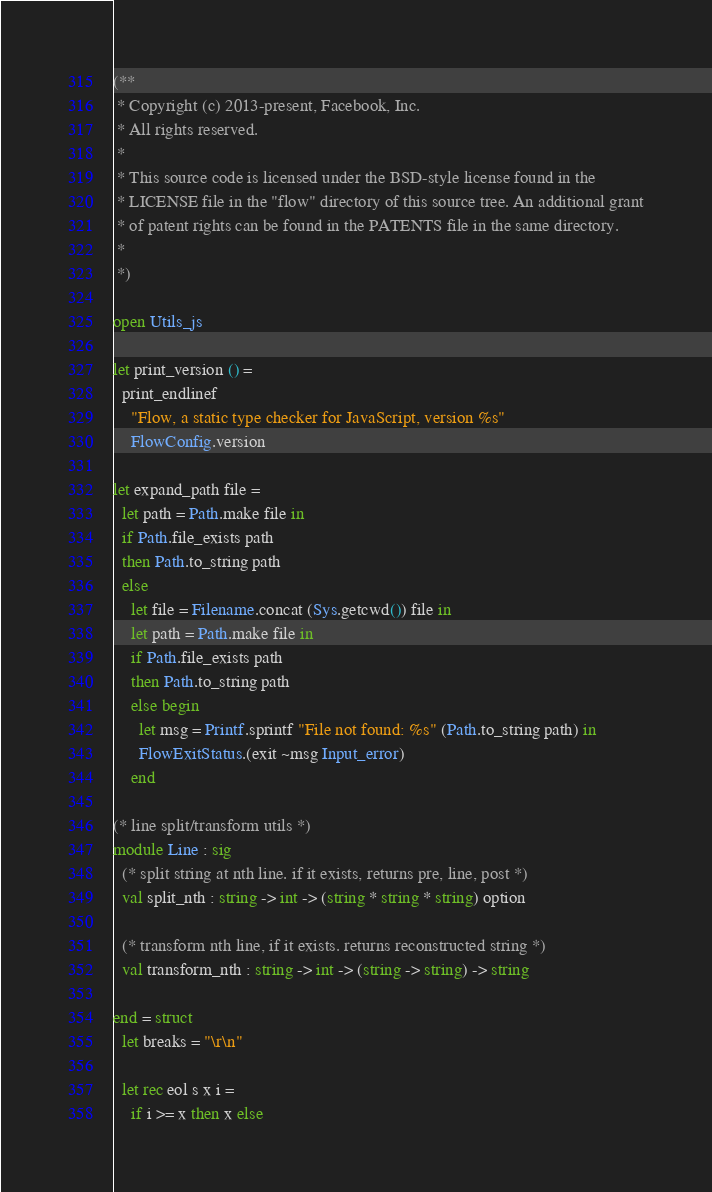Convert code to text. <code><loc_0><loc_0><loc_500><loc_500><_OCaml_>(**
 * Copyright (c) 2013-present, Facebook, Inc.
 * All rights reserved.
 *
 * This source code is licensed under the BSD-style license found in the
 * LICENSE file in the "flow" directory of this source tree. An additional grant
 * of patent rights can be found in the PATENTS file in the same directory.
 *
 *)

open Utils_js

let print_version () =
  print_endlinef
    "Flow, a static type checker for JavaScript, version %s"
    FlowConfig.version

let expand_path file =
  let path = Path.make file in
  if Path.file_exists path
  then Path.to_string path
  else
    let file = Filename.concat (Sys.getcwd()) file in
    let path = Path.make file in
    if Path.file_exists path
    then Path.to_string path
    else begin
      let msg = Printf.sprintf "File not found: %s" (Path.to_string path) in
      FlowExitStatus.(exit ~msg Input_error)
    end

(* line split/transform utils *)
module Line : sig
  (* split string at nth line. if it exists, returns pre, line, post *)
  val split_nth : string -> int -> (string * string * string) option

  (* transform nth line, if it exists. returns reconstructed string *)
  val transform_nth : string -> int -> (string -> string) -> string

end = struct
  let breaks = "\r\n"

  let rec eol s x i =
    if i >= x then x else</code> 